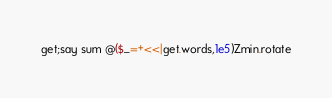Convert code to text. <code><loc_0><loc_0><loc_500><loc_500><_Perl_>get;say sum @($_=+<<|get.words,1e5)Zmin.rotate</code> 